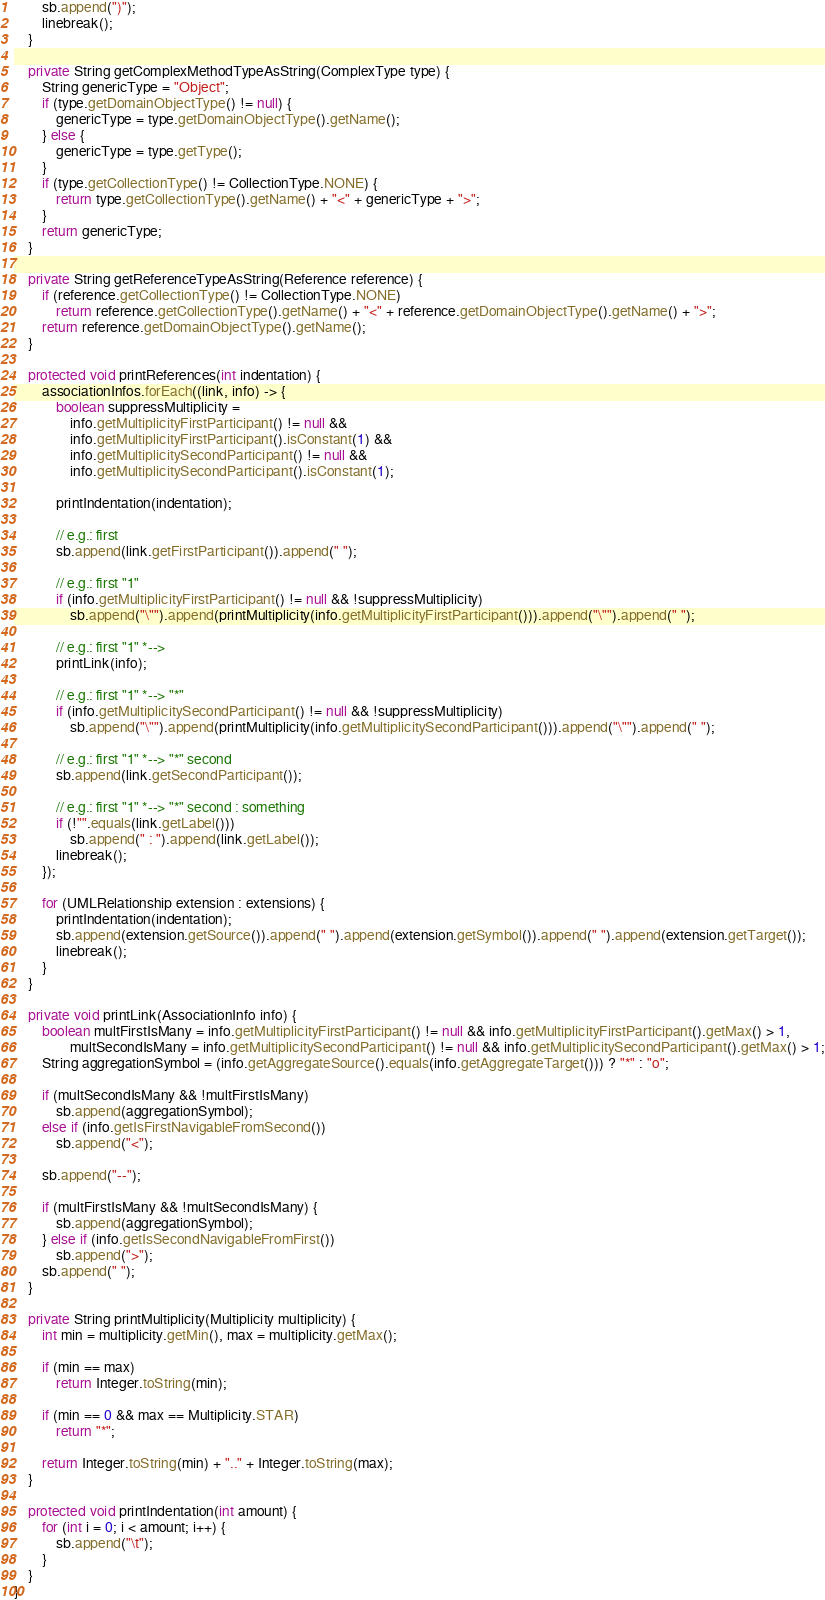Convert code to text. <code><loc_0><loc_0><loc_500><loc_500><_Java_>		sb.append(")");
		linebreak();
	}

	private String getComplexMethodTypeAsString(ComplexType type) {
		String genericType = "Object";
		if (type.getDomainObjectType() != null) {			
			genericType = type.getDomainObjectType().getName();
		} else {
			genericType = type.getType();
		}
		if (type.getCollectionType() != CollectionType.NONE) {
			return type.getCollectionType().getName() + "<" + genericType + ">";
		}
		return genericType;
	}

	private String getReferenceTypeAsString(Reference reference) {
		if (reference.getCollectionType() != CollectionType.NONE)
			return reference.getCollectionType().getName() + "<" + reference.getDomainObjectType().getName() + ">";
		return reference.getDomainObjectType().getName();
	}

	protected void printReferences(int indentation) {
		associationInfos.forEach((link, info) -> {
			boolean suppressMultiplicity = 
				info.getMultiplicityFirstParticipant() != null &&
				info.getMultiplicityFirstParticipant().isConstant(1) && 
				info.getMultiplicitySecondParticipant() != null &&
				info.getMultiplicitySecondParticipant().isConstant(1);

			printIndentation(indentation);

			// e.g.: first
			sb.append(link.getFirstParticipant()).append(" ");			

			// e.g.: first "1"
			if (info.getMultiplicityFirstParticipant() != null && !suppressMultiplicity)
				sb.append("\"").append(printMultiplicity(info.getMultiplicityFirstParticipant())).append("\"").append(" ");	

			// e.g.: first "1" *-->
			printLink(info);

			// e.g.: first "1" *--> "*"
			if (info.getMultiplicitySecondParticipant() != null && !suppressMultiplicity)
				sb.append("\"").append(printMultiplicity(info.getMultiplicitySecondParticipant())).append("\"").append(" ");

			// e.g.: first "1" *--> "*" second
			sb.append(link.getSecondParticipant());

			// e.g.: first "1" *--> "*" second : something
			if (!"".equals(link.getLabel()))
		 		sb.append(" : ").append(link.getLabel());
		 	linebreak();
		});

		for (UMLRelationship extension : extensions) {
			printIndentation(indentation);
			sb.append(extension.getSource()).append(" ").append(extension.getSymbol()).append(" ").append(extension.getTarget());
			linebreak();
		}
	}

	private void printLink(AssociationInfo info) {
		boolean multFirstIsMany = info.getMultiplicityFirstParticipant() != null && info.getMultiplicityFirstParticipant().getMax() > 1,
				multSecondIsMany = info.getMultiplicitySecondParticipant() != null && info.getMultiplicitySecondParticipant().getMax() > 1;
		String aggregationSymbol = (info.getAggregateSource().equals(info.getAggregateTarget())) ? "*" : "o";

		if (multSecondIsMany && !multFirstIsMany)
			sb.append(aggregationSymbol);
		else if (info.getIsFirstNavigableFromSecond())
			sb.append("<");

		sb.append("--");

		if (multFirstIsMany && !multSecondIsMany) {
			sb.append(aggregationSymbol); 
		} else if (info.getIsSecondNavigableFromFirst())
			sb.append(">");							
		sb.append(" ");
	}

	private String printMultiplicity(Multiplicity multiplicity) {
		int min = multiplicity.getMin(), max = multiplicity.getMax();

		if (min == max)
			return Integer.toString(min);
		
		if (min == 0 && max == Multiplicity.STAR)
			return "*";

		return Integer.toString(min) + ".." + Integer.toString(max);
	}

	protected void printIndentation(int amount) {
		for (int i = 0; i < amount; i++) {
			sb.append("\t");
		}
	}
}
</code> 